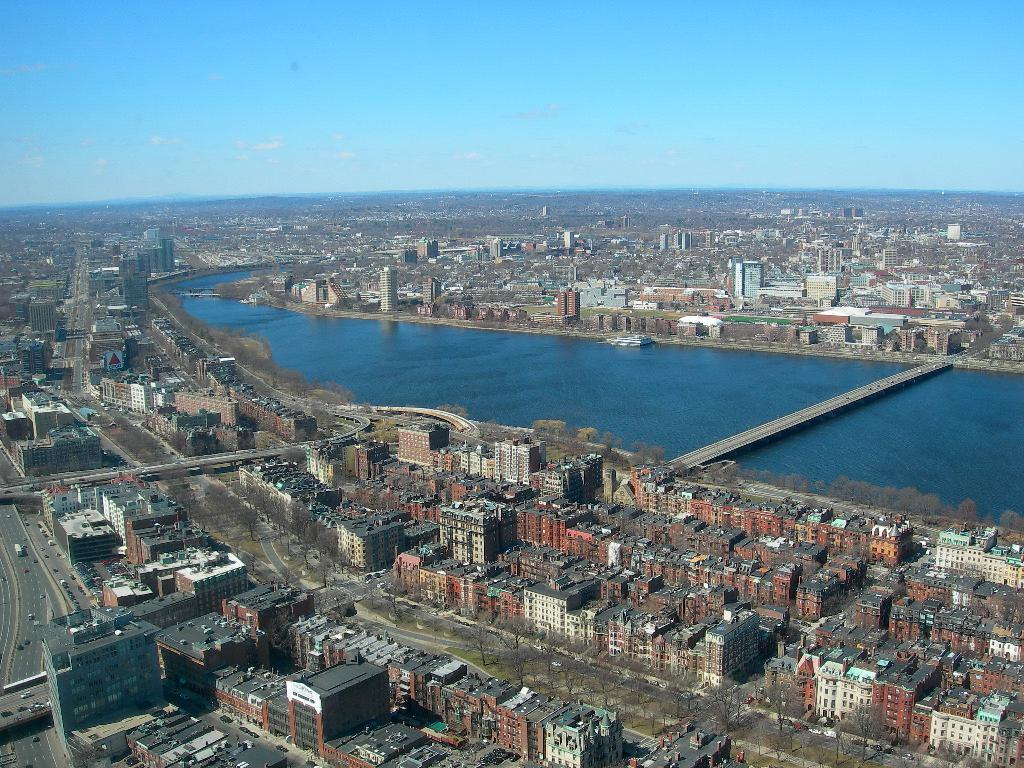What type of structures can be seen in the image? There are many buildings in the image. What natural feature is present in the image? There is a river flowing in the image. How does the river connect different parts of the image? There is a bridge across the river in the image. What can be seen in the background of the image? The sky is visible in the background of the image. What type of apparel is being worn by the river in the image? There is no apparel present in the image, as the river is a natural feature and not a person or object that can wear clothing. 